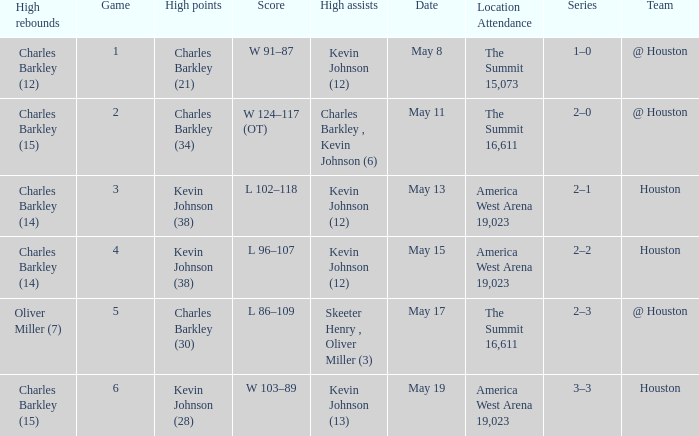Who did the high assists in the game where Charles Barkley (21) did the high points? Kevin Johnson (12). 